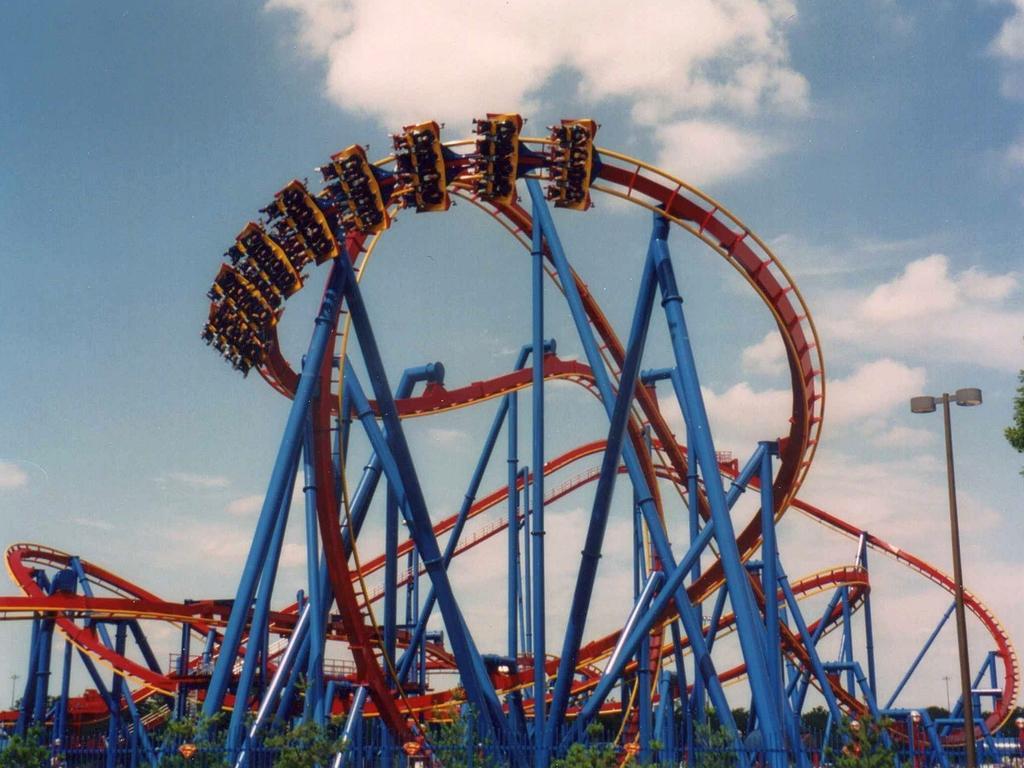Describe this image in one or two sentences. In this image we can see roller coaster and trees. In the background we can see sky and clouds. 